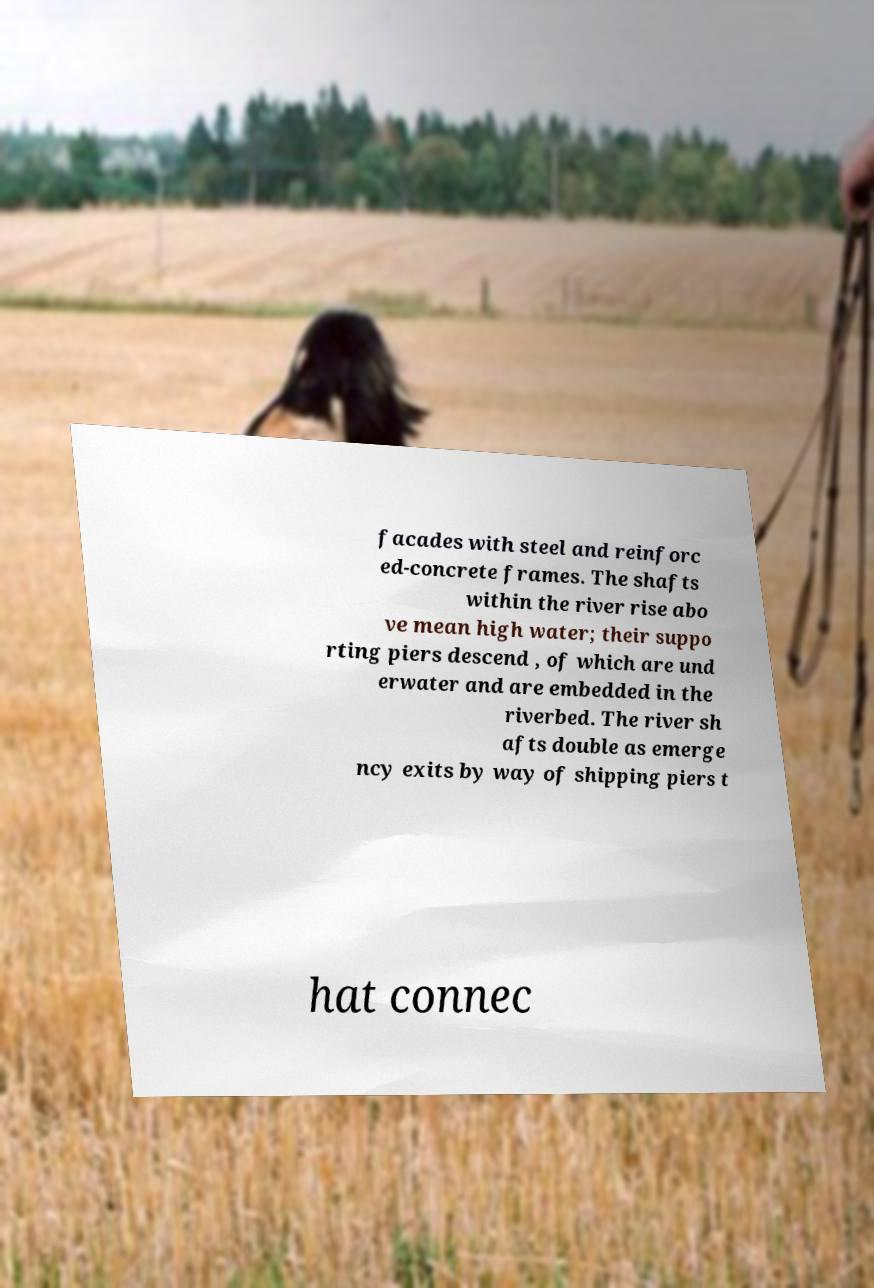Can you read and provide the text displayed in the image?This photo seems to have some interesting text. Can you extract and type it out for me? facades with steel and reinforc ed-concrete frames. The shafts within the river rise abo ve mean high water; their suppo rting piers descend , of which are und erwater and are embedded in the riverbed. The river sh afts double as emerge ncy exits by way of shipping piers t hat connec 